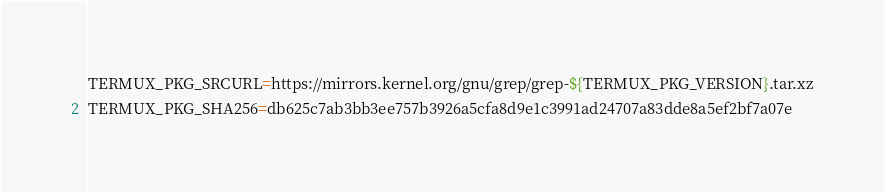<code> <loc_0><loc_0><loc_500><loc_500><_Bash_>TERMUX_PKG_SRCURL=https://mirrors.kernel.org/gnu/grep/grep-${TERMUX_PKG_VERSION}.tar.xz
TERMUX_PKG_SHA256=db625c7ab3bb3ee757b3926a5cfa8d9e1c3991ad24707a83dde8a5ef2bf7a07e
</code> 